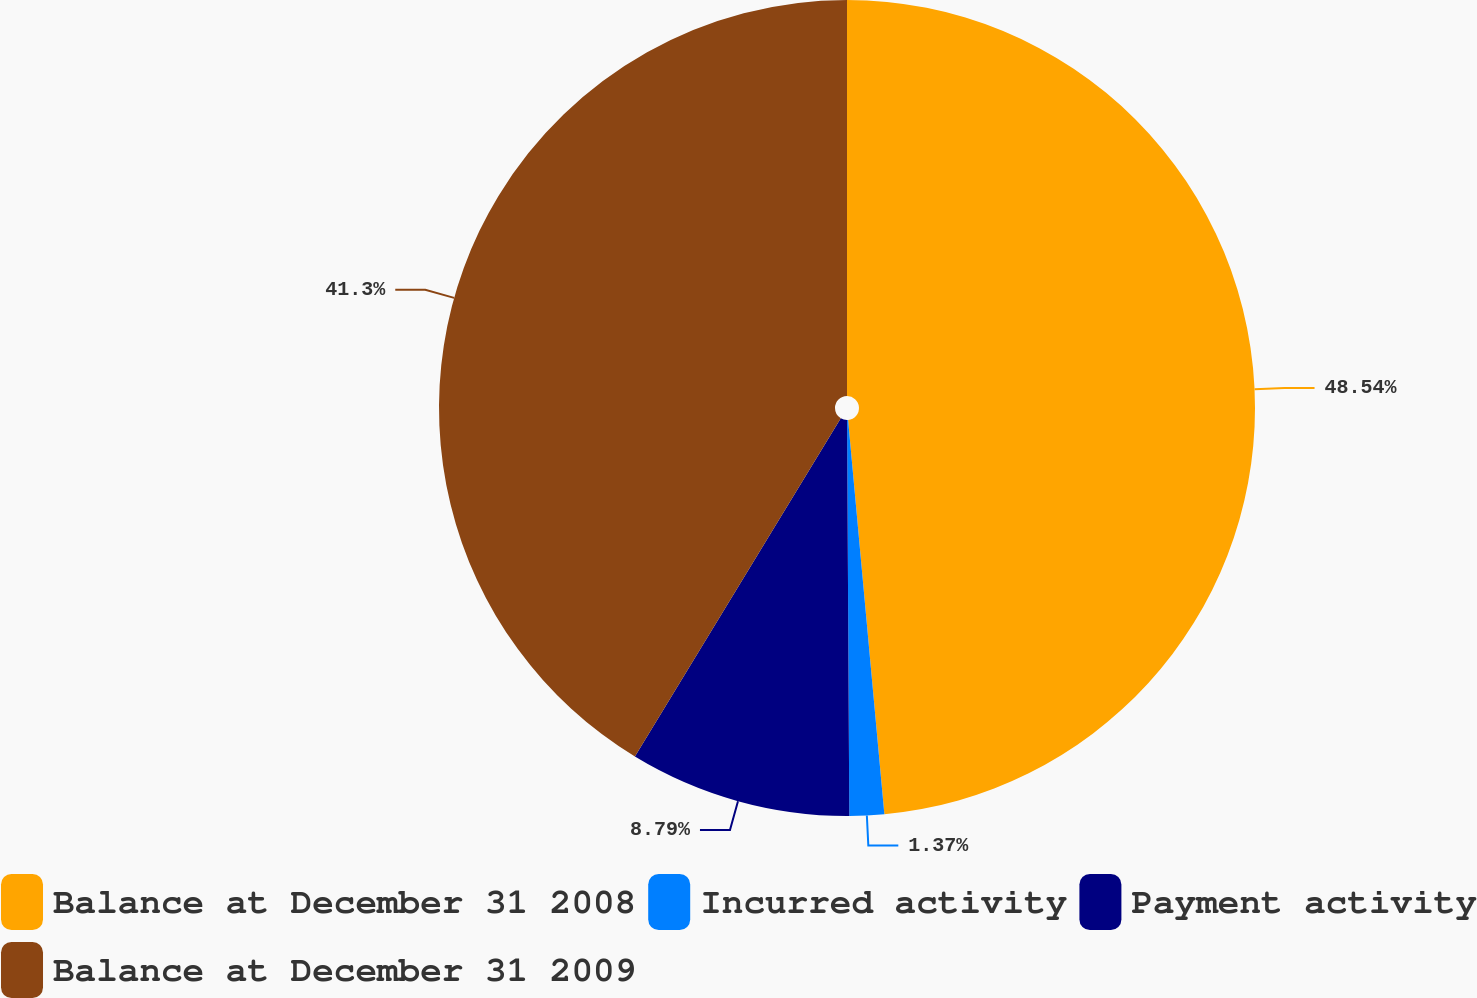<chart> <loc_0><loc_0><loc_500><loc_500><pie_chart><fcel>Balance at December 31 2008<fcel>Incurred activity<fcel>Payment activity<fcel>Balance at December 31 2009<nl><fcel>48.54%<fcel>1.37%<fcel>8.79%<fcel>41.3%<nl></chart> 